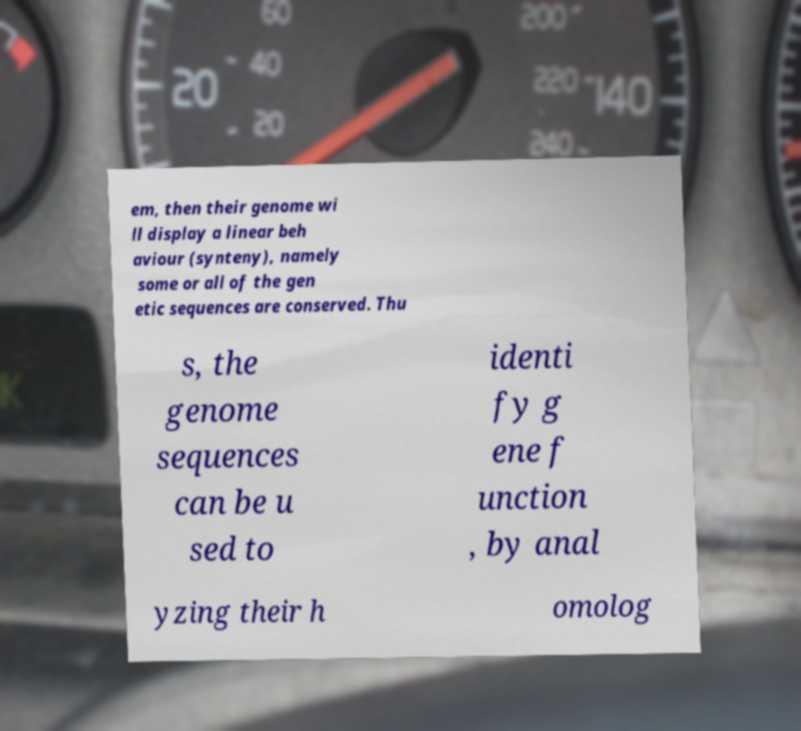For documentation purposes, I need the text within this image transcribed. Could you provide that? em, then their genome wi ll display a linear beh aviour (synteny), namely some or all of the gen etic sequences are conserved. Thu s, the genome sequences can be u sed to identi fy g ene f unction , by anal yzing their h omolog 